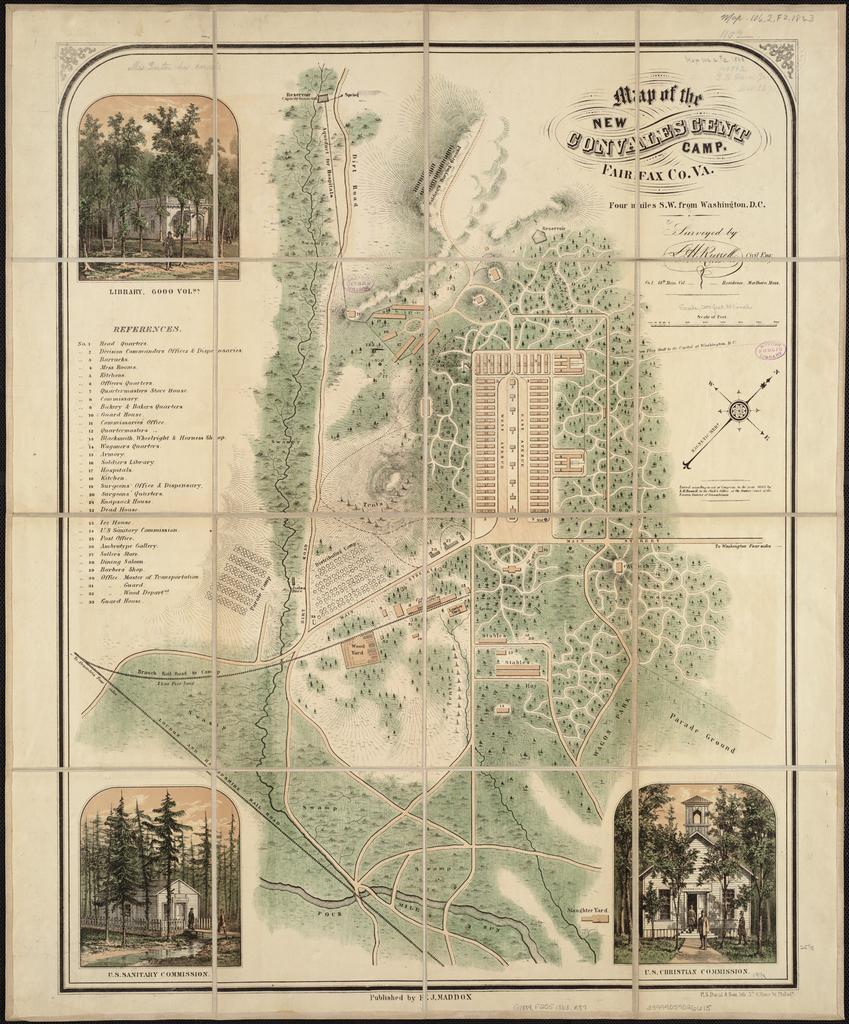What is the main subject of the paper in the image? The paper contains pictures of trees and buildings. Are there any other elements on the paper besides the pictures? Yes, there is text on the paper. Can you describe the central feature of the paper? There is a map in the middle of the paper. What type of yam is being used as a quilt on the side of the paper? There is no yam or quilt present on the paper; it contains pictures of trees, buildings, text, and a map. 